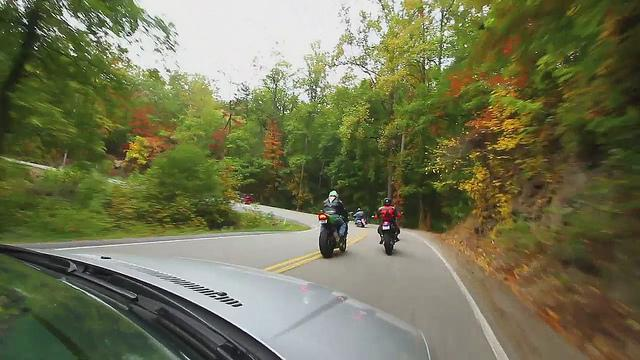How many motorcycles are on the highway apparently ahead of the vehicle driving? Please explain your reasoning. three. There's one by the curve and two behind. 